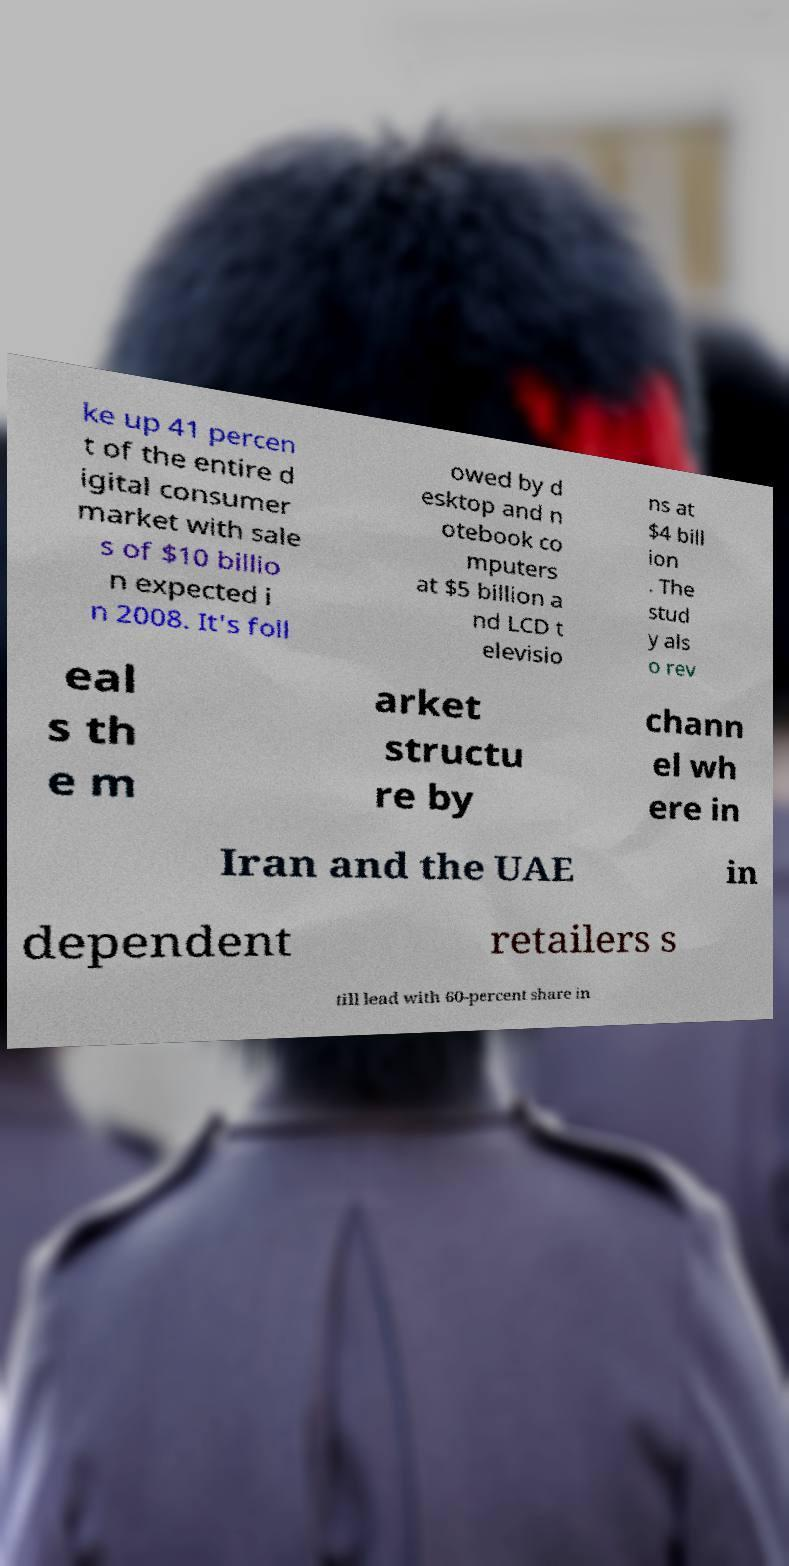I need the written content from this picture converted into text. Can you do that? ke up 41 percen t of the entire d igital consumer market with sale s of $10 billio n expected i n 2008. It's foll owed by d esktop and n otebook co mputers at $5 billion a nd LCD t elevisio ns at $4 bill ion . The stud y als o rev eal s th e m arket structu re by chann el wh ere in Iran and the UAE in dependent retailers s till lead with 60-percent share in 